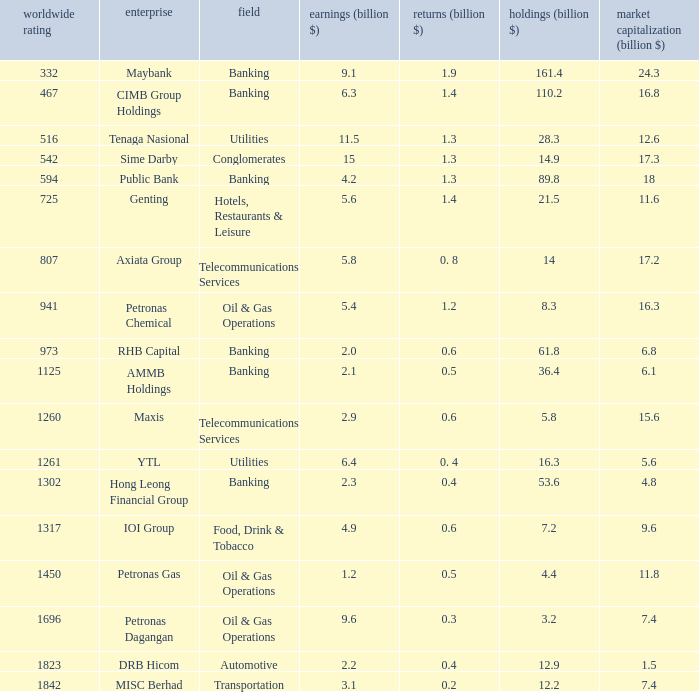Could you parse the entire table? {'header': ['worldwide rating', 'enterprise', 'field', 'earnings (billion $)', 'returns (billion $)', 'holdings (billion $)', 'market capitalization (billion $)'], 'rows': [['332', 'Maybank', 'Banking', '9.1', '1.9', '161.4', '24.3'], ['467', 'CIMB Group Holdings', 'Banking', '6.3', '1.4', '110.2', '16.8'], ['516', 'Tenaga Nasional', 'Utilities', '11.5', '1.3', '28.3', '12.6'], ['542', 'Sime Darby', 'Conglomerates', '15', '1.3', '14.9', '17.3'], ['594', 'Public Bank', 'Banking', '4.2', '1.3', '89.8', '18'], ['725', 'Genting', 'Hotels, Restaurants & Leisure', '5.6', '1.4', '21.5', '11.6'], ['807', 'Axiata Group', 'Telecommunications Services', '5.8', '0. 8', '14', '17.2'], ['941', 'Petronas Chemical', 'Oil & Gas Operations', '5.4', '1.2', '8.3', '16.3'], ['973', 'RHB Capital', 'Banking', '2.0', '0.6', '61.8', '6.8'], ['1125', 'AMMB Holdings', 'Banking', '2.1', '0.5', '36.4', '6.1'], ['1260', 'Maxis', 'Telecommunications Services', '2.9', '0.6', '5.8', '15.6'], ['1261', 'YTL', 'Utilities', '6.4', '0. 4', '16.3', '5.6'], ['1302', 'Hong Leong Financial Group', 'Banking', '2.3', '0.4', '53.6', '4.8'], ['1317', 'IOI Group', 'Food, Drink & Tobacco', '4.9', '0.6', '7.2', '9.6'], ['1450', 'Petronas Gas', 'Oil & Gas Operations', '1.2', '0.5', '4.4', '11.8'], ['1696', 'Petronas Dagangan', 'Oil & Gas Operations', '9.6', '0.3', '3.2', '7.4'], ['1823', 'DRB Hicom', 'Automotive', '2.2', '0.4', '12.9', '1.5'], ['1842', 'MISC Berhad', 'Transportation', '3.1', '0.2', '12.2', '7.4']]} Determine the returns for market value of 1 0.5. 